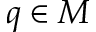<formula> <loc_0><loc_0><loc_500><loc_500>q \in M</formula> 